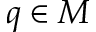<formula> <loc_0><loc_0><loc_500><loc_500>q \in M</formula> 